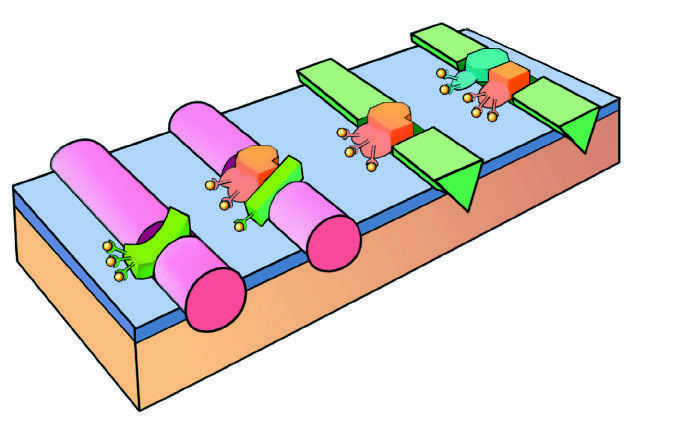does the initial reaction complex consist of a protease, a substrate, and a reaction accelerator assembled on a platelet phospholipid surface?
Answer the question using a single word or phrase. Yes 